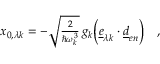<formula> <loc_0><loc_0><loc_500><loc_500>\begin{array} { r } { x _ { 0 , \lambda k } = - \sqrt { \frac { 2 } { \hbar { \omega } _ { k } ^ { 3 } } } \, g _ { k } \left ( \underline { e } _ { \lambda k } \cdot \underline { d } _ { e n } \right ) \quad , } \end{array}</formula> 